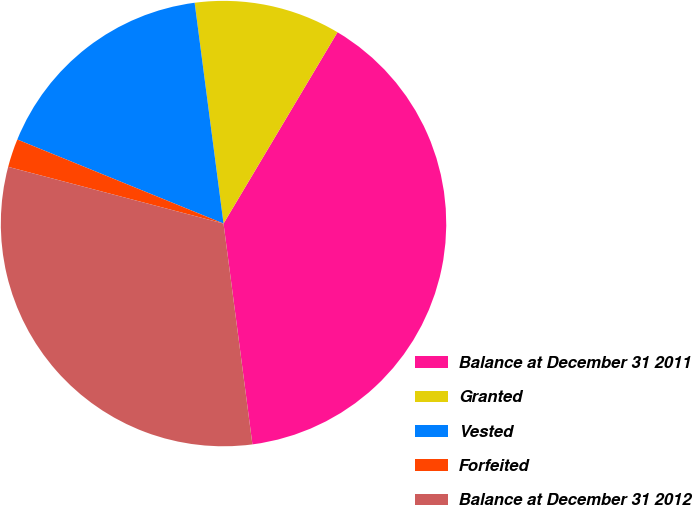Convert chart to OTSL. <chart><loc_0><loc_0><loc_500><loc_500><pie_chart><fcel>Balance at December 31 2011<fcel>Granted<fcel>Vested<fcel>Forfeited<fcel>Balance at December 31 2012<nl><fcel>39.38%<fcel>10.62%<fcel>16.77%<fcel>2.06%<fcel>31.17%<nl></chart> 